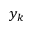Convert formula to latex. <formula><loc_0><loc_0><loc_500><loc_500>y _ { k }</formula> 